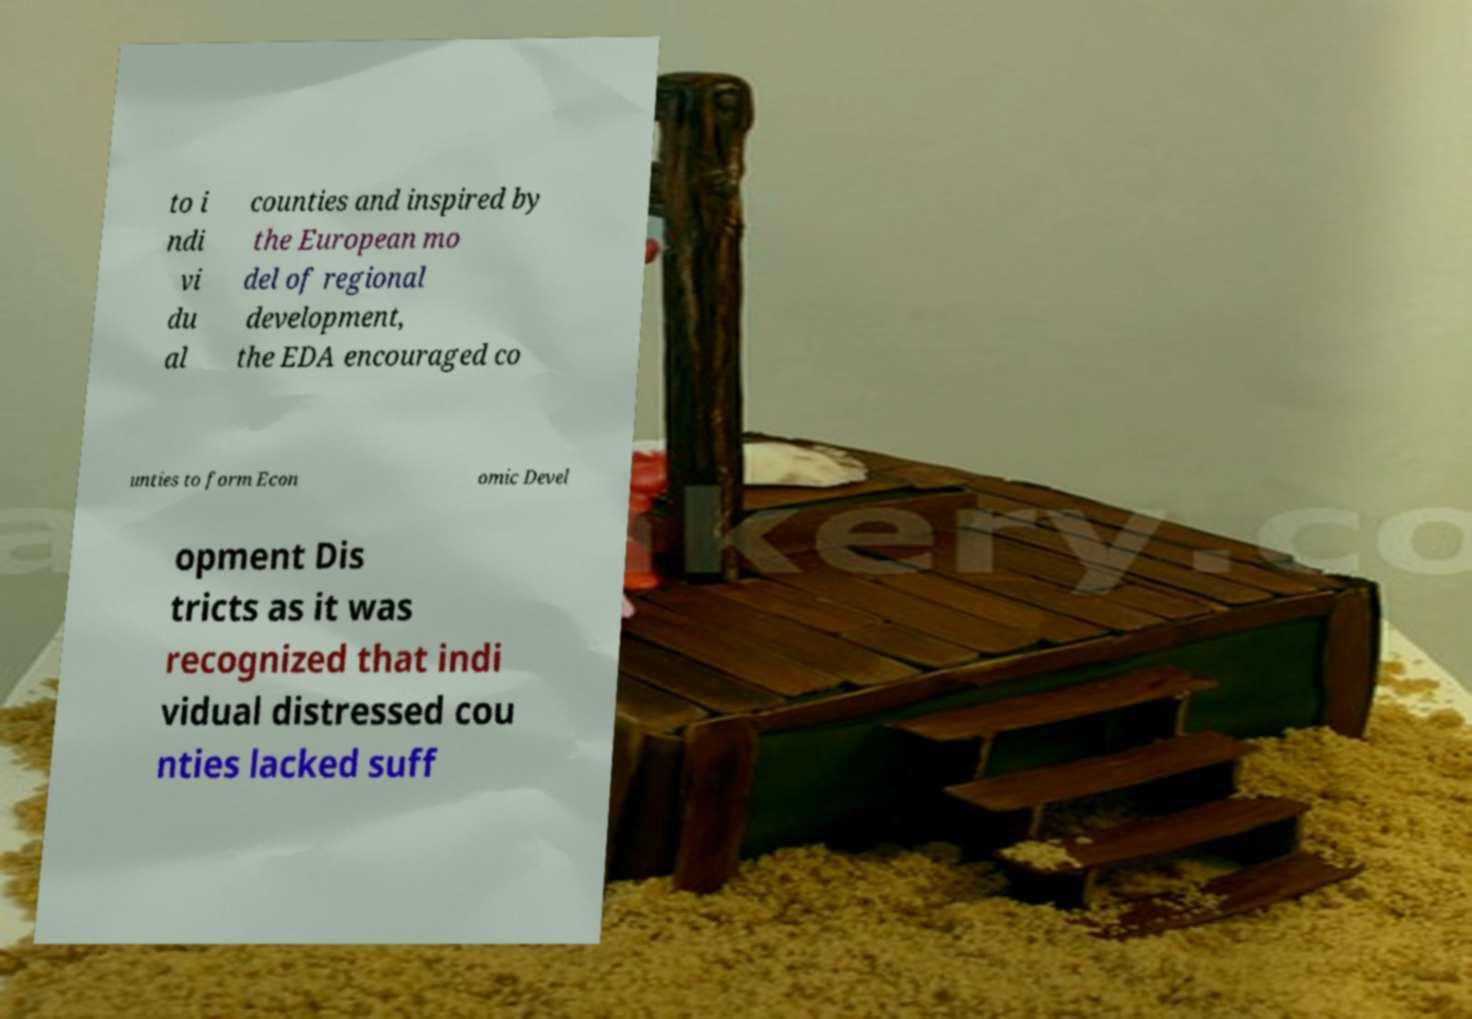For documentation purposes, I need the text within this image transcribed. Could you provide that? to i ndi vi du al counties and inspired by the European mo del of regional development, the EDA encouraged co unties to form Econ omic Devel opment Dis tricts as it was recognized that indi vidual distressed cou nties lacked suff 